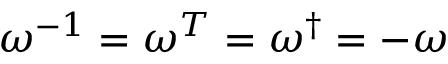Convert formula to latex. <formula><loc_0><loc_0><loc_500><loc_500>\omega ^ { - 1 } = \omega ^ { T } = \omega ^ { \dagger } = - \omega</formula> 